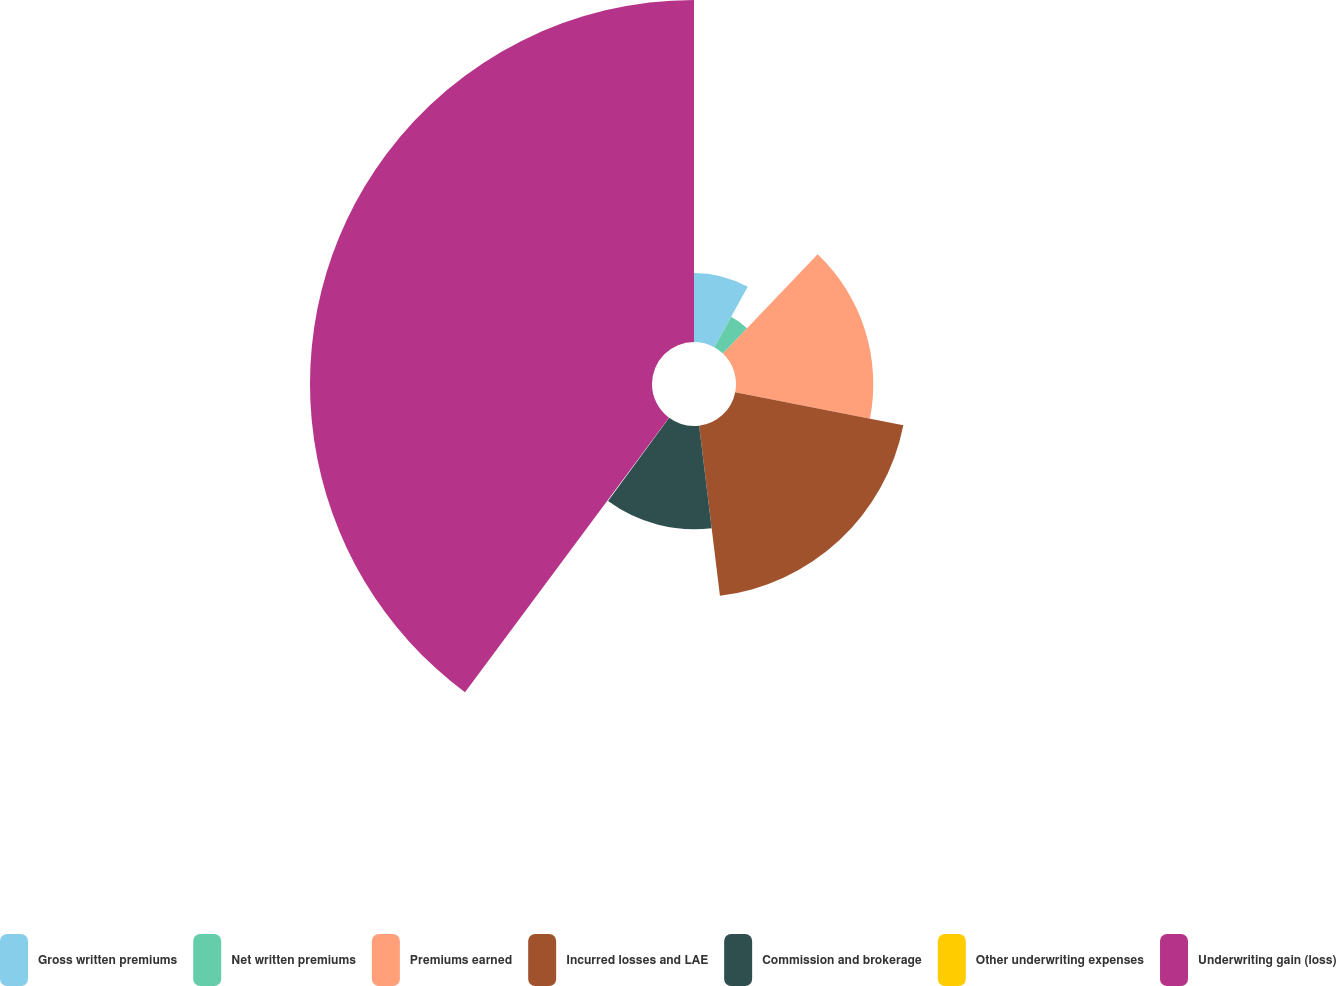<chart> <loc_0><loc_0><loc_500><loc_500><pie_chart><fcel>Gross written premiums<fcel>Net written premiums<fcel>Premiums earned<fcel>Incurred losses and LAE<fcel>Commission and brokerage<fcel>Other underwriting expenses<fcel>Underwriting gain (loss)<nl><fcel>8.04%<fcel>4.07%<fcel>15.99%<fcel>19.96%<fcel>12.02%<fcel>0.09%<fcel>39.83%<nl></chart> 